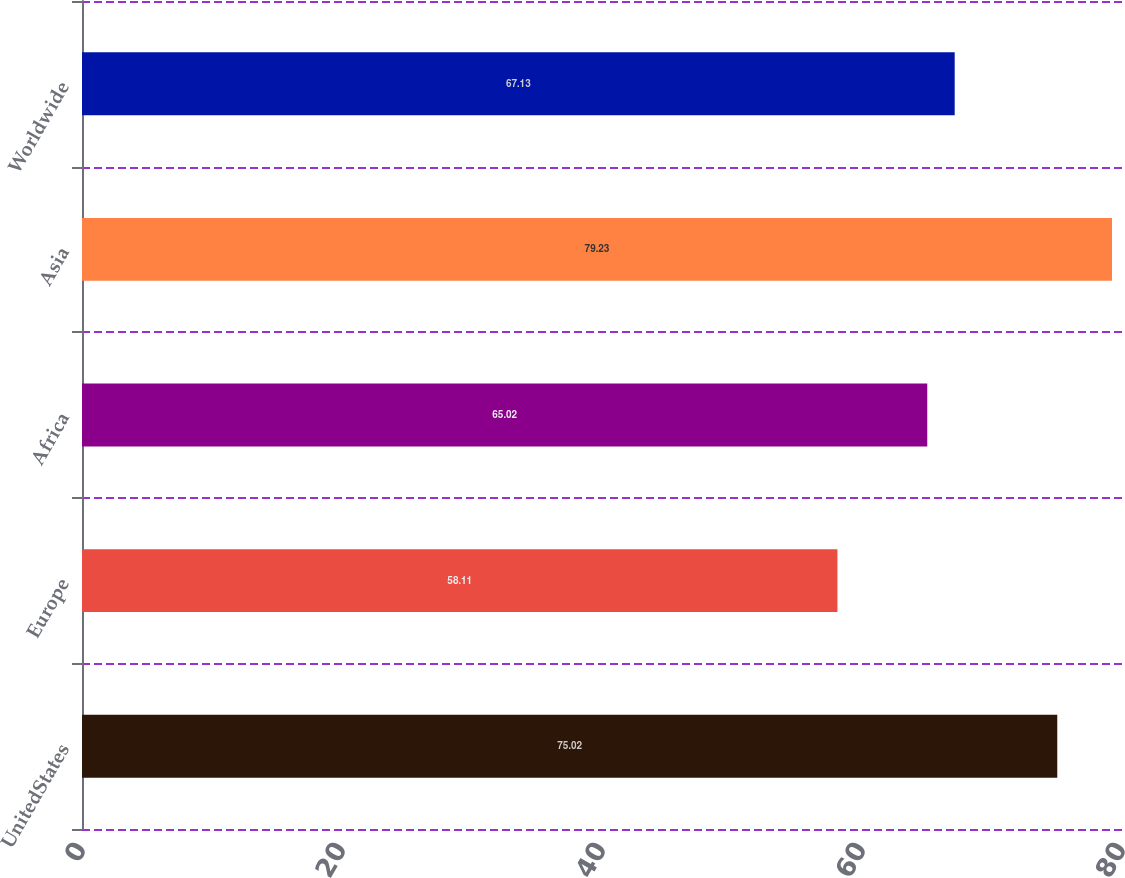Convert chart. <chart><loc_0><loc_0><loc_500><loc_500><bar_chart><fcel>UnitedStates<fcel>Europe<fcel>Africa<fcel>Asia<fcel>Worldwide<nl><fcel>75.02<fcel>58.11<fcel>65.02<fcel>79.23<fcel>67.13<nl></chart> 